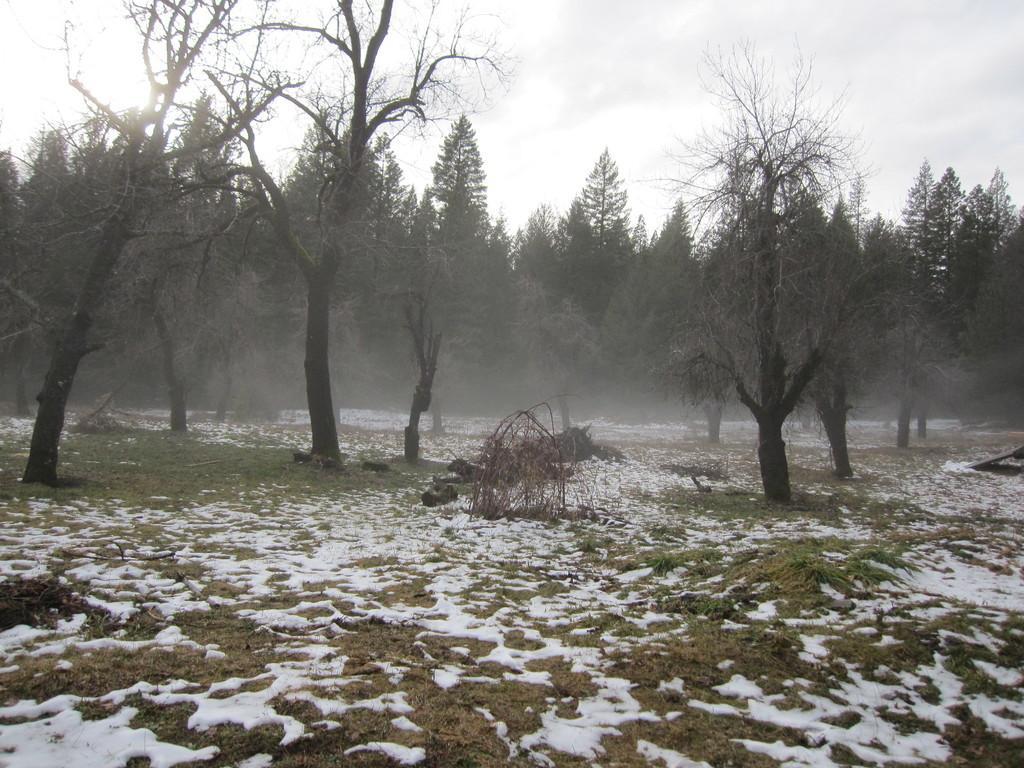In one or two sentences, can you explain what this image depicts? In this image I can see the ground, some grass, some snow and few trees which are green and black in color. In the background I can see the sky. 